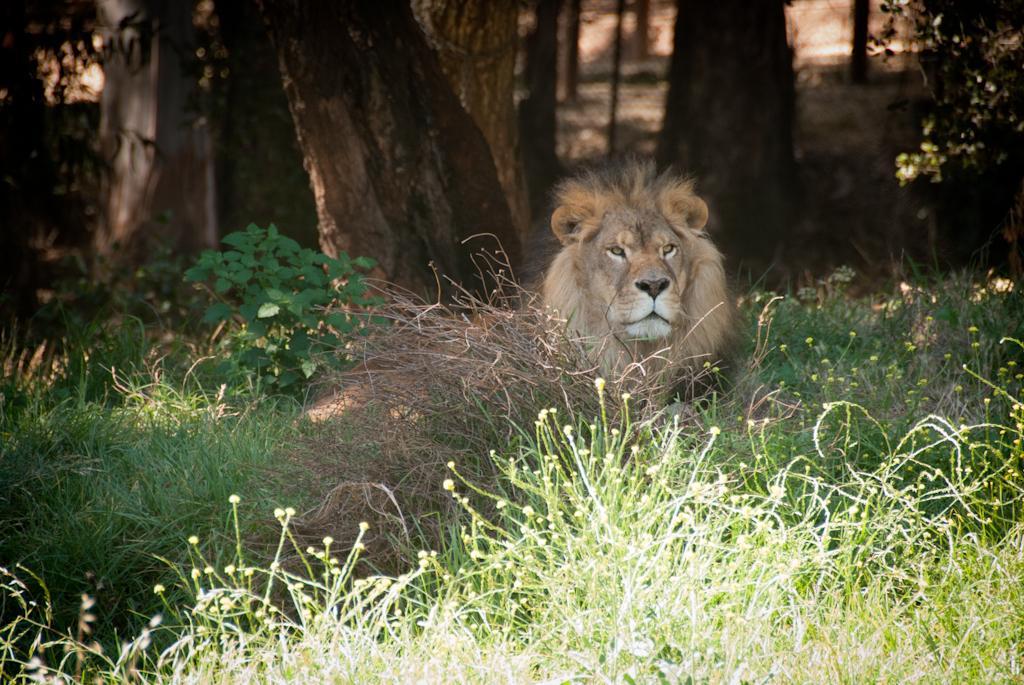In one or two sentences, can you explain what this image depicts? Background portion of the picture is blurry and the fence is visible. In this picture we can see the tree trunks, plants and the twigs. We can see a lion. 